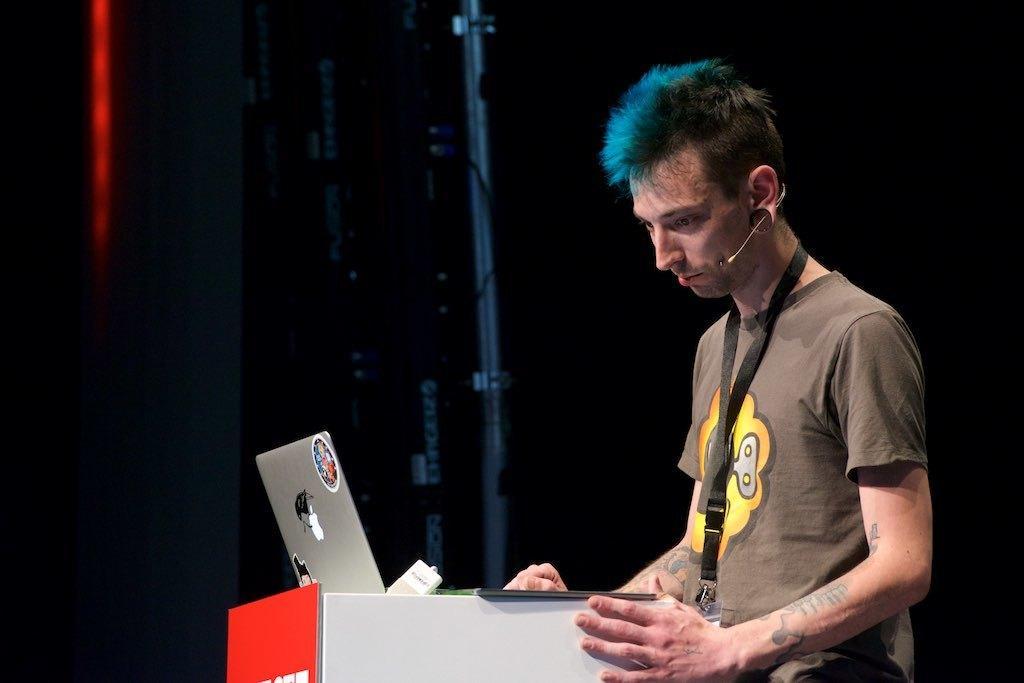Can you describe this image briefly? In this picture there is a boy on the right side of the image and there is a laptop in front of him on a desk, there is a rod in the background area of the image. 